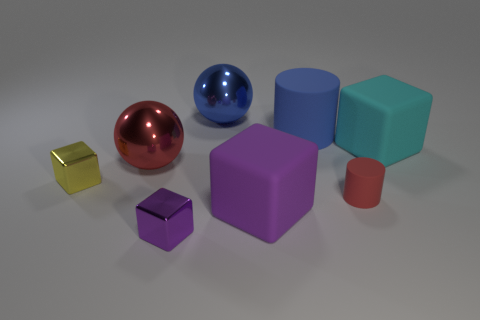How many purple cubes must be subtracted to get 1 purple cubes? 1 Add 2 purple metallic things. How many objects exist? 10 Subtract all cylinders. How many objects are left? 6 Add 3 small cylinders. How many small cylinders are left? 4 Add 2 tiny green metal cylinders. How many tiny green metal cylinders exist? 2 Subtract 0 gray cylinders. How many objects are left? 8 Subtract all large cyan balls. Subtract all big blue matte things. How many objects are left? 7 